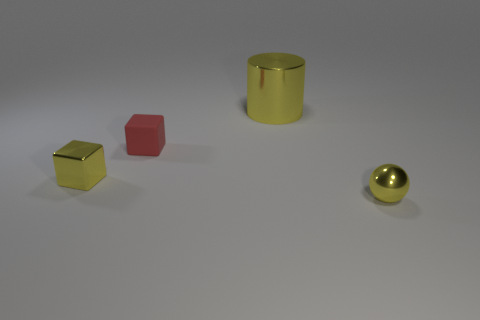What is the cube that is on the right side of the shiny object to the left of the large thing made of?
Offer a terse response. Rubber. What is the small yellow cube that is behind the shiny sphere made of?
Ensure brevity in your answer.  Metal. Is the color of the small object that is on the right side of the cylinder the same as the large metallic cylinder?
Offer a very short reply. Yes. What size is the red thing that is on the left side of the yellow shiny object that is to the right of the big object?
Make the answer very short. Small. Is the number of things right of the rubber object greater than the number of brown cylinders?
Ensure brevity in your answer.  Yes. There is a yellow shiny thing that is left of the yellow shiny cylinder; does it have the same size as the red rubber object?
Provide a succinct answer. Yes. What is the color of the metallic object that is to the right of the rubber cube and in front of the red rubber thing?
Offer a very short reply. Yellow. What shape is the red thing that is the same size as the metal sphere?
Ensure brevity in your answer.  Cube. Is there a small thing of the same color as the cylinder?
Your answer should be very brief. Yes. Are there the same number of yellow metallic spheres that are on the right side of the small red object and large purple balls?
Offer a terse response. No. 